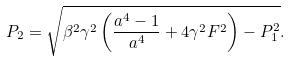<formula> <loc_0><loc_0><loc_500><loc_500>P _ { 2 } = \sqrt { \beta ^ { 2 } \gamma ^ { 2 } \left ( \frac { a ^ { 4 } - 1 } { a ^ { 4 } } + 4 \gamma ^ { 2 } F ^ { 2 } \right ) - P _ { 1 } ^ { 2 } } .</formula> 